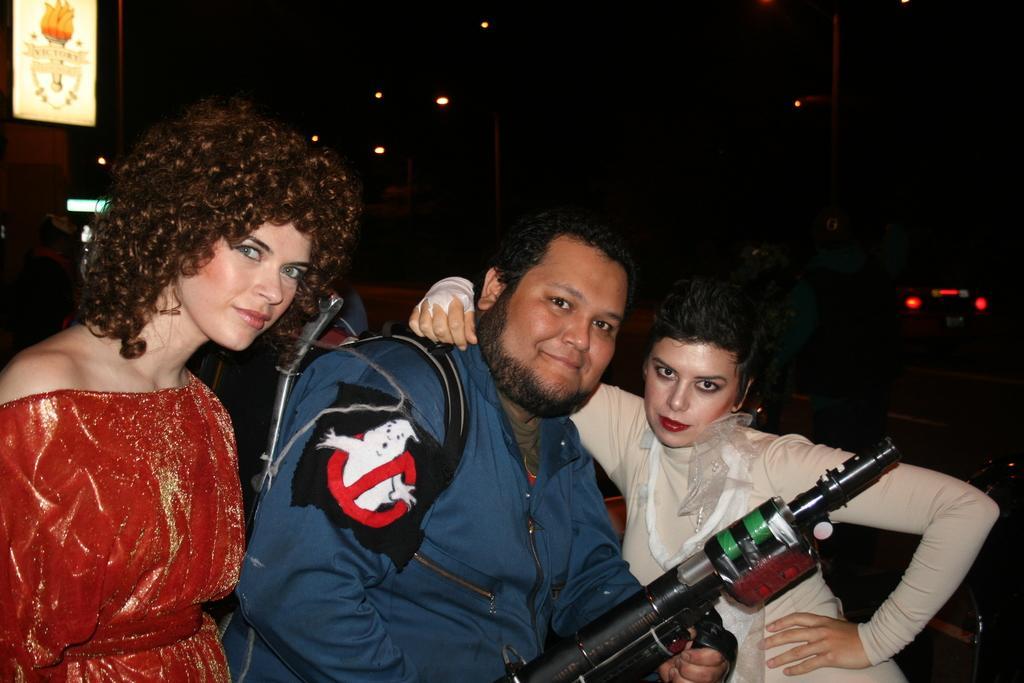Please provide a concise description of this image. In this image we can see three people are standing, there a man is holding a gun in the hand, there are lights, the background is dark. 